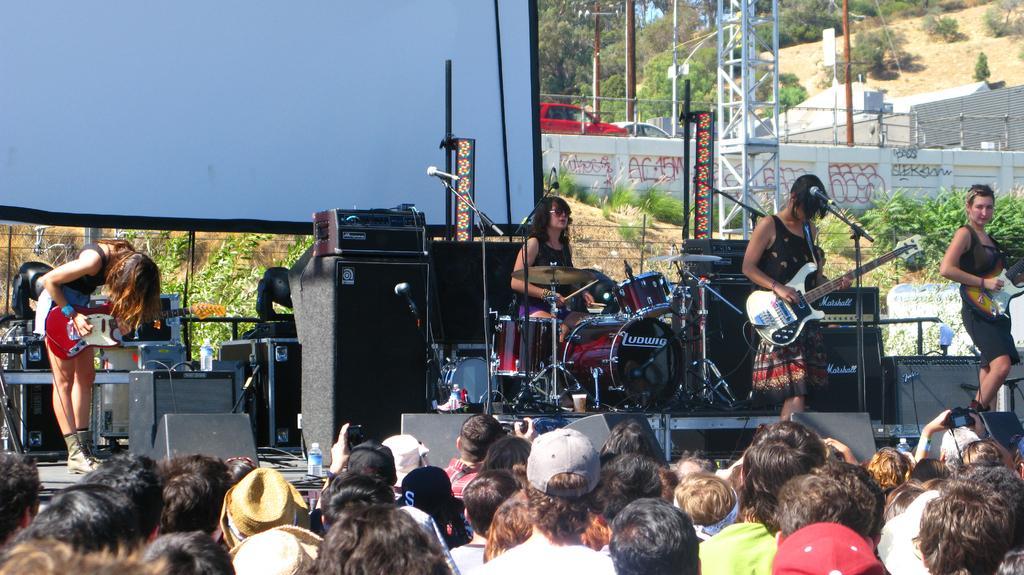Can you describe this image briefly? In this image, we can see few peoples are playing a musical instruments. They are on the stage and few items are placed on the stage. Background, we can see vehicles, poles, pillars, fencing and trees, plants. On left side we can see a screen. At the bottom of the image, we can see human heads. Few are wearing cap, hats on his heads. 